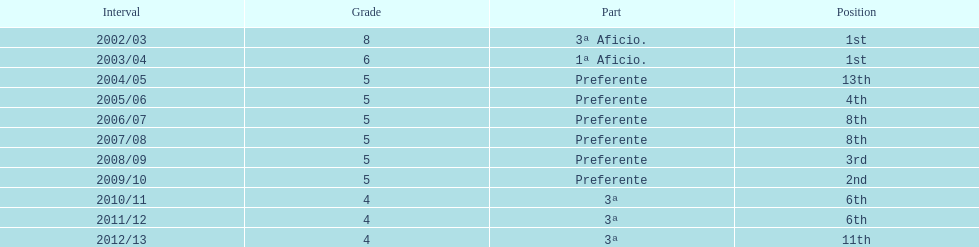How long has internacional de madrid cf been playing in the 3ª division? 3. 